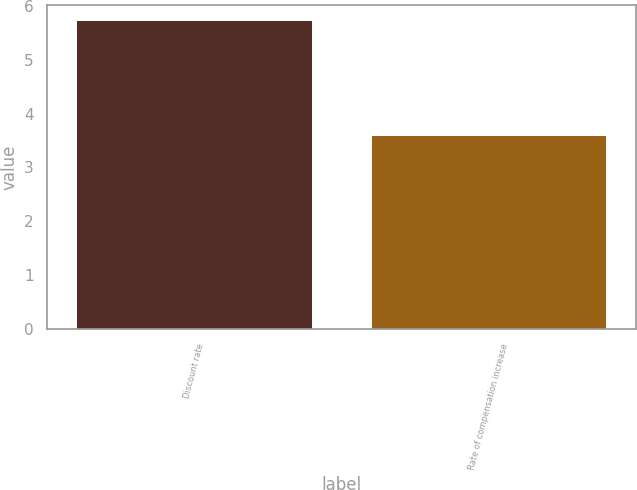Convert chart. <chart><loc_0><loc_0><loc_500><loc_500><bar_chart><fcel>Discount rate<fcel>Rate of compensation increase<nl><fcel>5.73<fcel>3.6<nl></chart> 